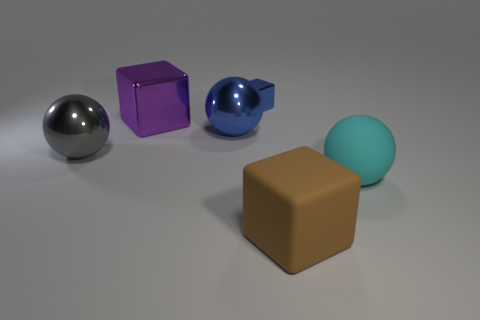Add 2 tiny blue metallic objects. How many objects exist? 8 Subtract 0 yellow blocks. How many objects are left? 6 Subtract all tiny blue shiny blocks. Subtract all blue shiny cylinders. How many objects are left? 5 Add 2 gray metal objects. How many gray metal objects are left? 3 Add 5 cyan matte spheres. How many cyan matte spheres exist? 6 